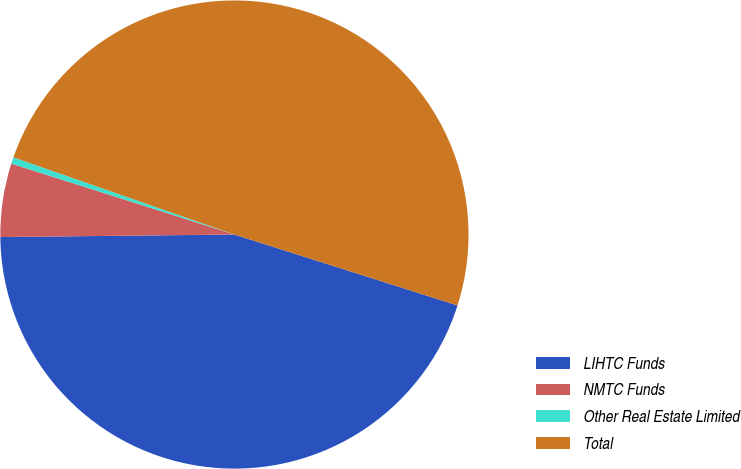Convert chart to OTSL. <chart><loc_0><loc_0><loc_500><loc_500><pie_chart><fcel>LIHTC Funds<fcel>NMTC Funds<fcel>Other Real Estate Limited<fcel>Total<nl><fcel>44.93%<fcel>5.07%<fcel>0.45%<fcel>49.55%<nl></chart> 